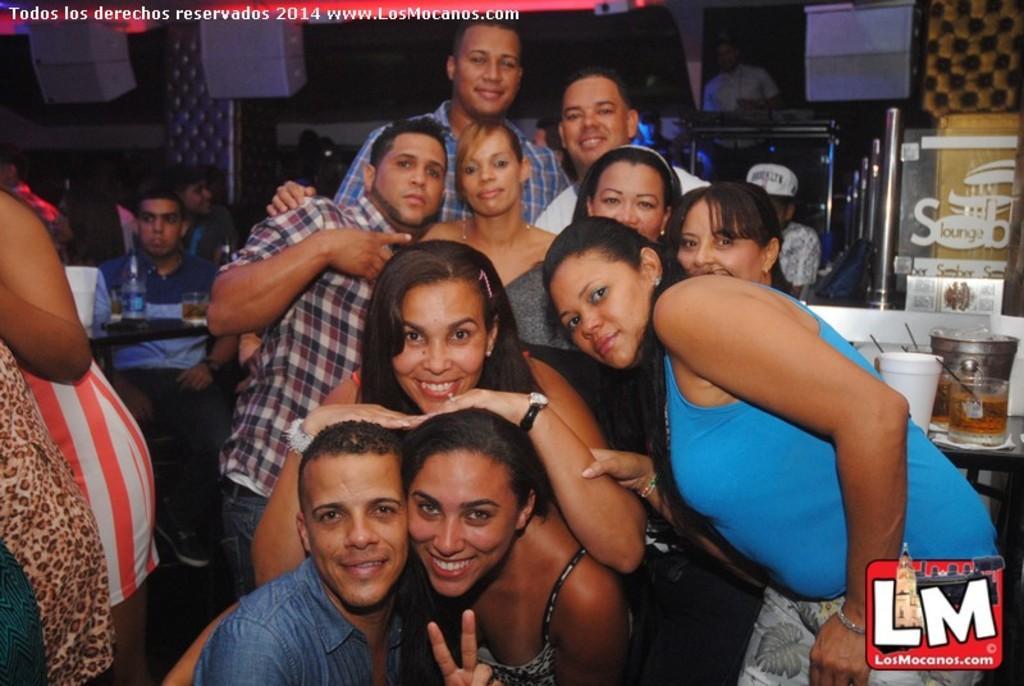Please provide a concise description of this image. In this image I see a group of people and few of them are smiling. In the background, I see a table and there is a bottle and a glass on it and there are also few people over here. 